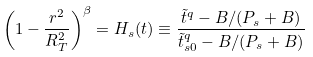Convert formula to latex. <formula><loc_0><loc_0><loc_500><loc_500>\left ( 1 - \frac { r ^ { 2 } } { R _ { T } ^ { 2 } } \right ) ^ { \beta } = H _ { s } ( t ) \equiv \frac { { \tilde { t } } ^ { q } - B / ( P _ { s } + B ) } { { \tilde { t } _ { s 0 } } ^ { q } - B / ( P _ { s } + B ) }</formula> 